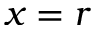Convert formula to latex. <formula><loc_0><loc_0><loc_500><loc_500>x = r</formula> 